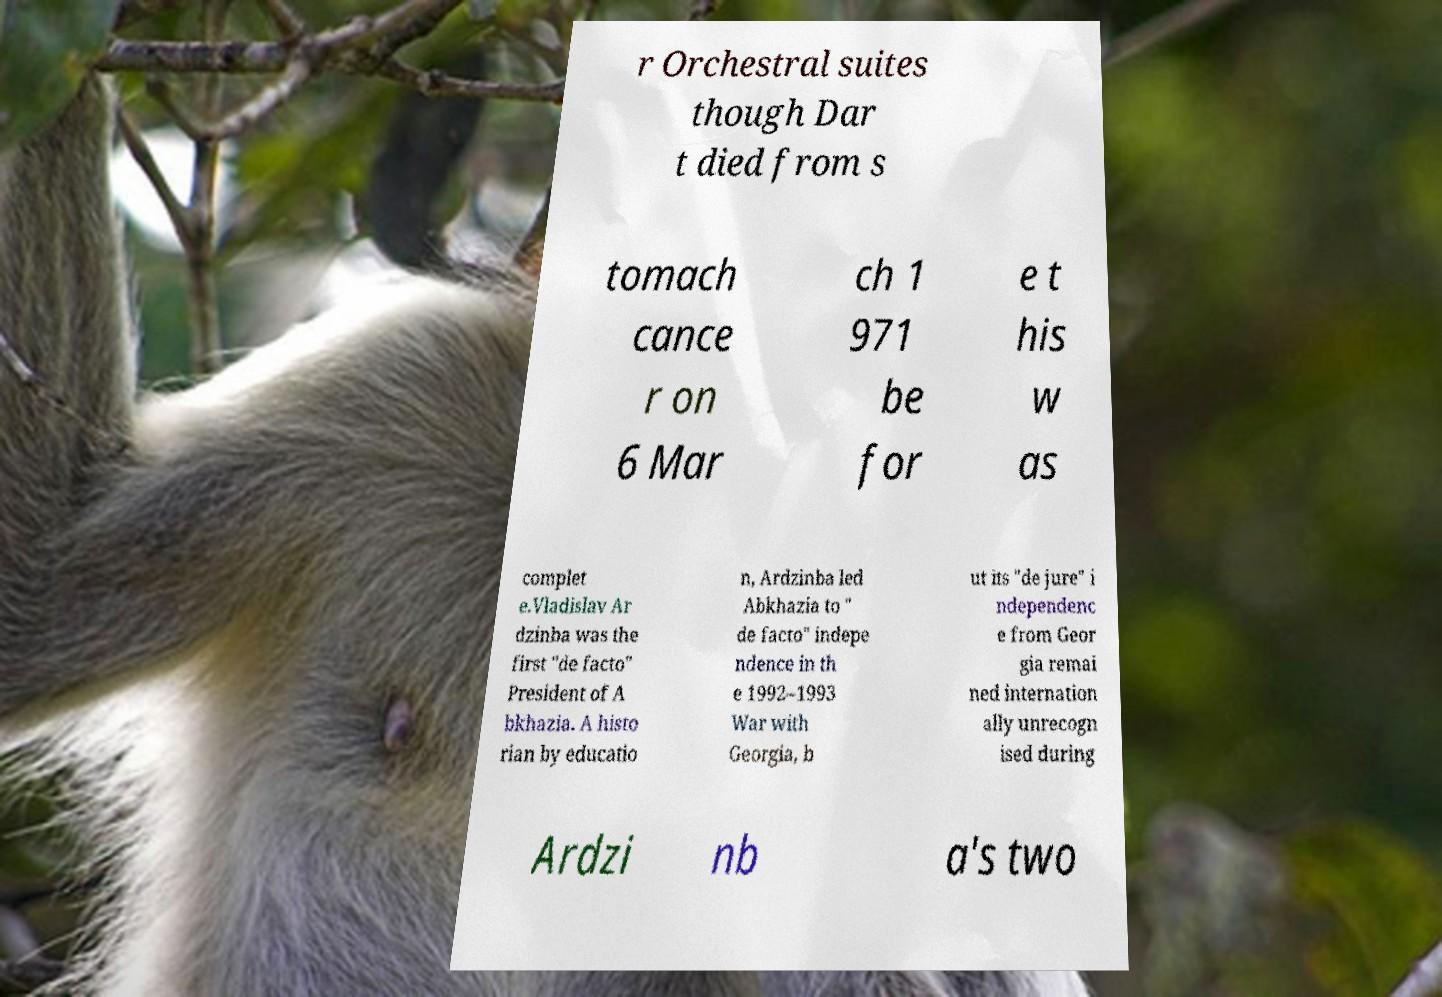I need the written content from this picture converted into text. Can you do that? r Orchestral suites though Dar t died from s tomach cance r on 6 Mar ch 1 971 be for e t his w as complet e.Vladislav Ar dzinba was the first "de facto" President of A bkhazia. A histo rian by educatio n, Ardzinba led Abkhazia to " de facto" indepe ndence in th e 1992–1993 War with Georgia, b ut its "de jure" i ndependenc e from Geor gia remai ned internation ally unrecogn ised during Ardzi nb a's two 